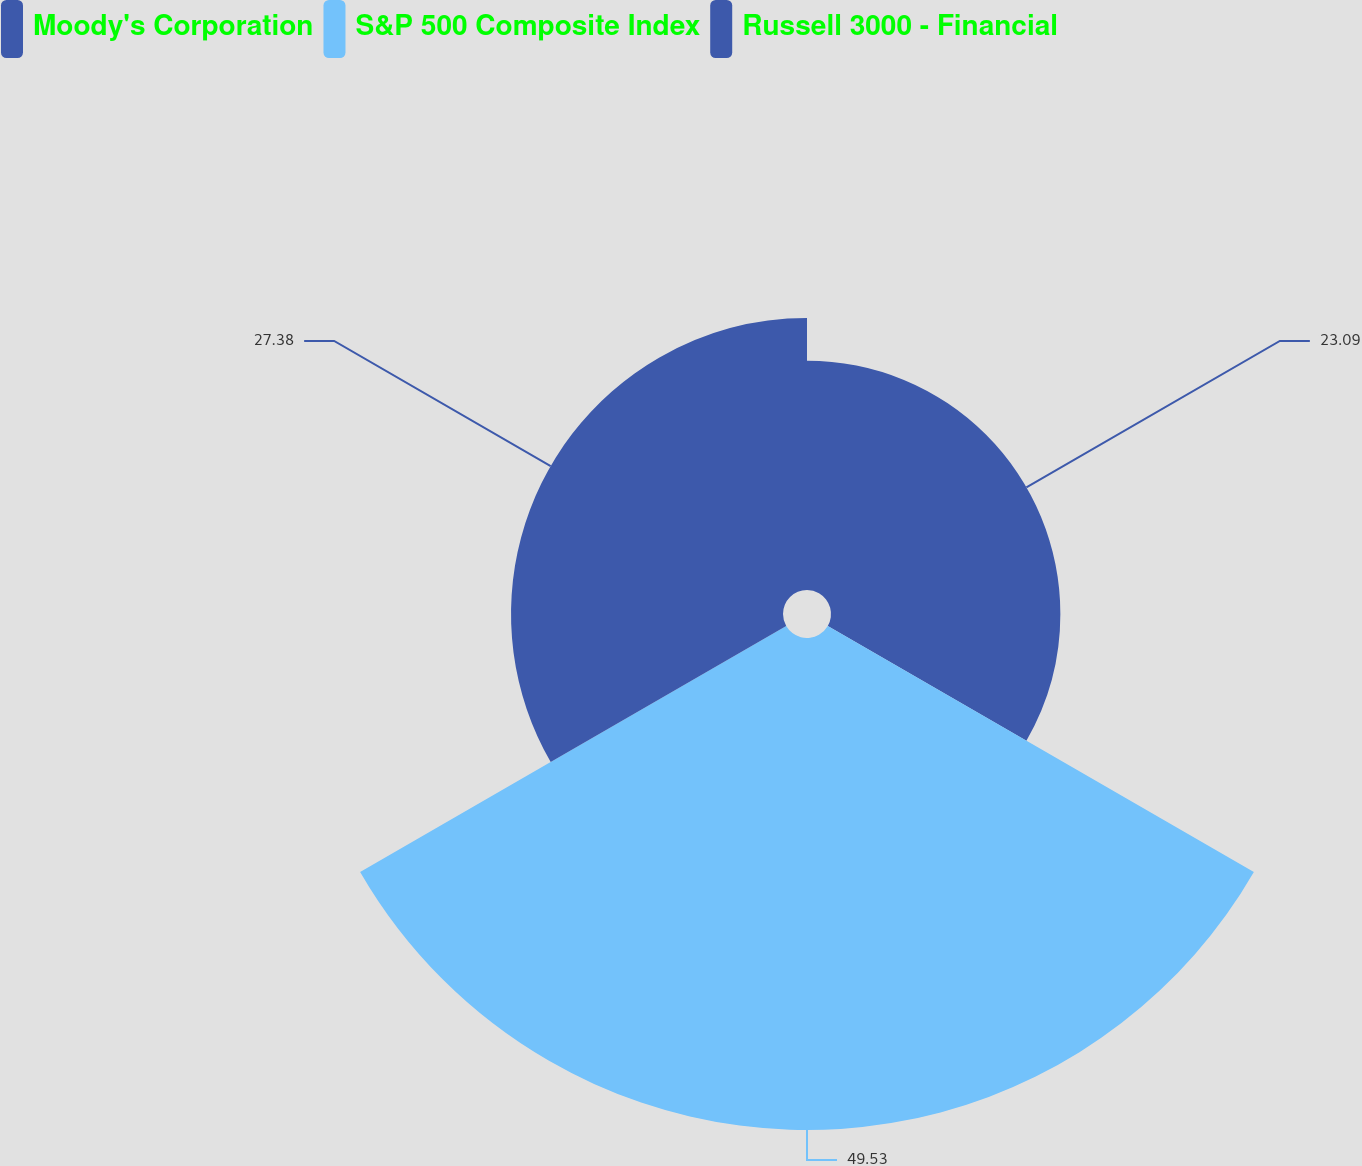Convert chart. <chart><loc_0><loc_0><loc_500><loc_500><pie_chart><fcel>Moody's Corporation<fcel>S&P 500 Composite Index<fcel>Russell 3000 - Financial<nl><fcel>23.09%<fcel>49.53%<fcel>27.38%<nl></chart> 